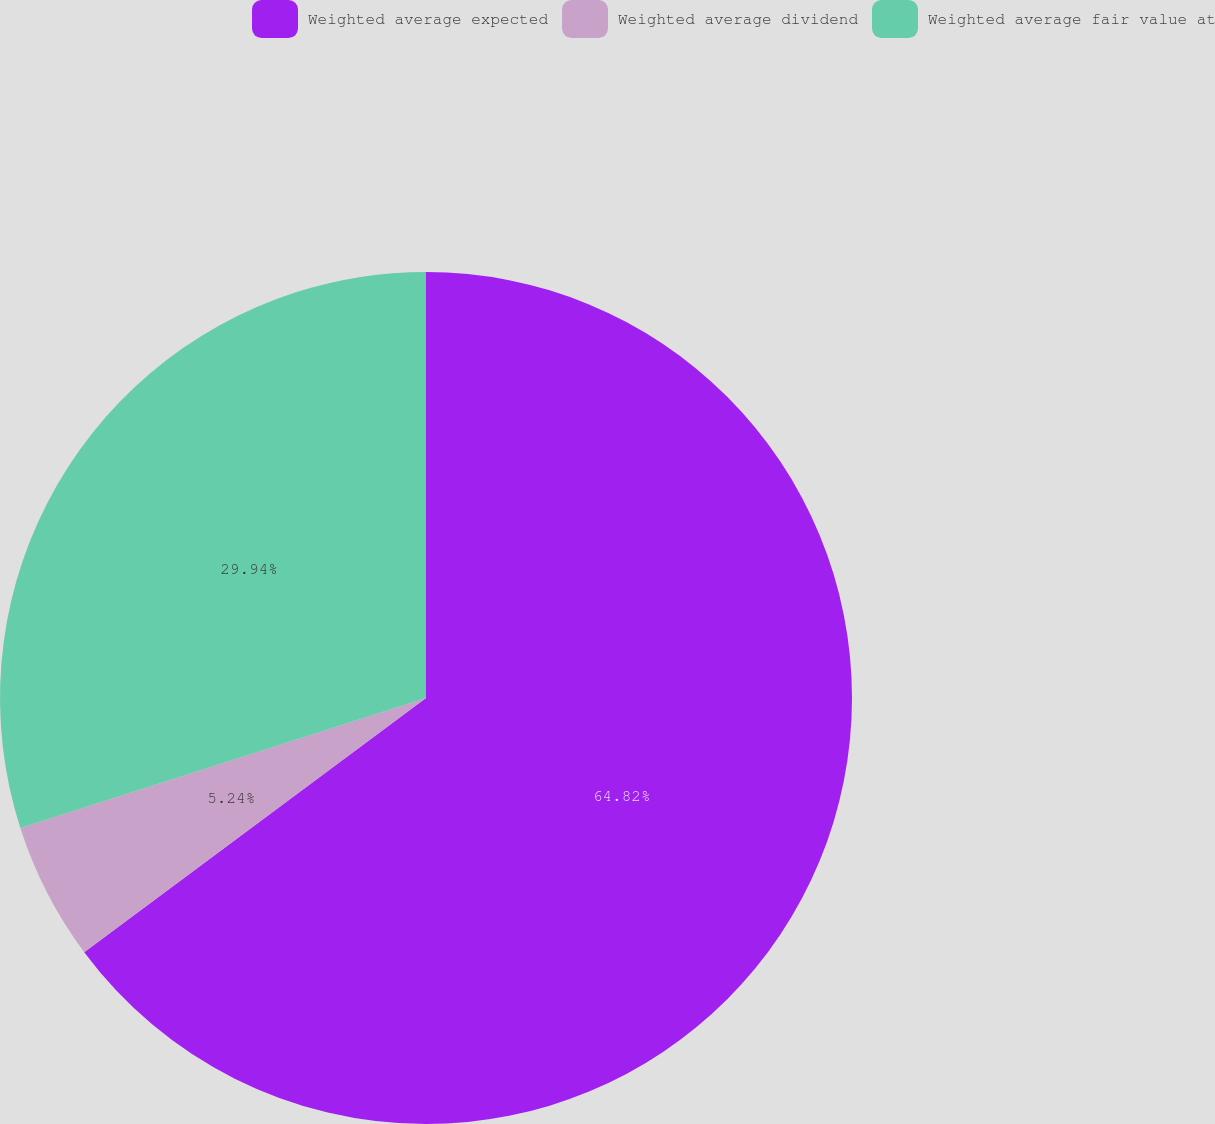Convert chart. <chart><loc_0><loc_0><loc_500><loc_500><pie_chart><fcel>Weighted average expected<fcel>Weighted average dividend<fcel>Weighted average fair value at<nl><fcel>64.82%<fcel>5.24%<fcel>29.94%<nl></chart> 